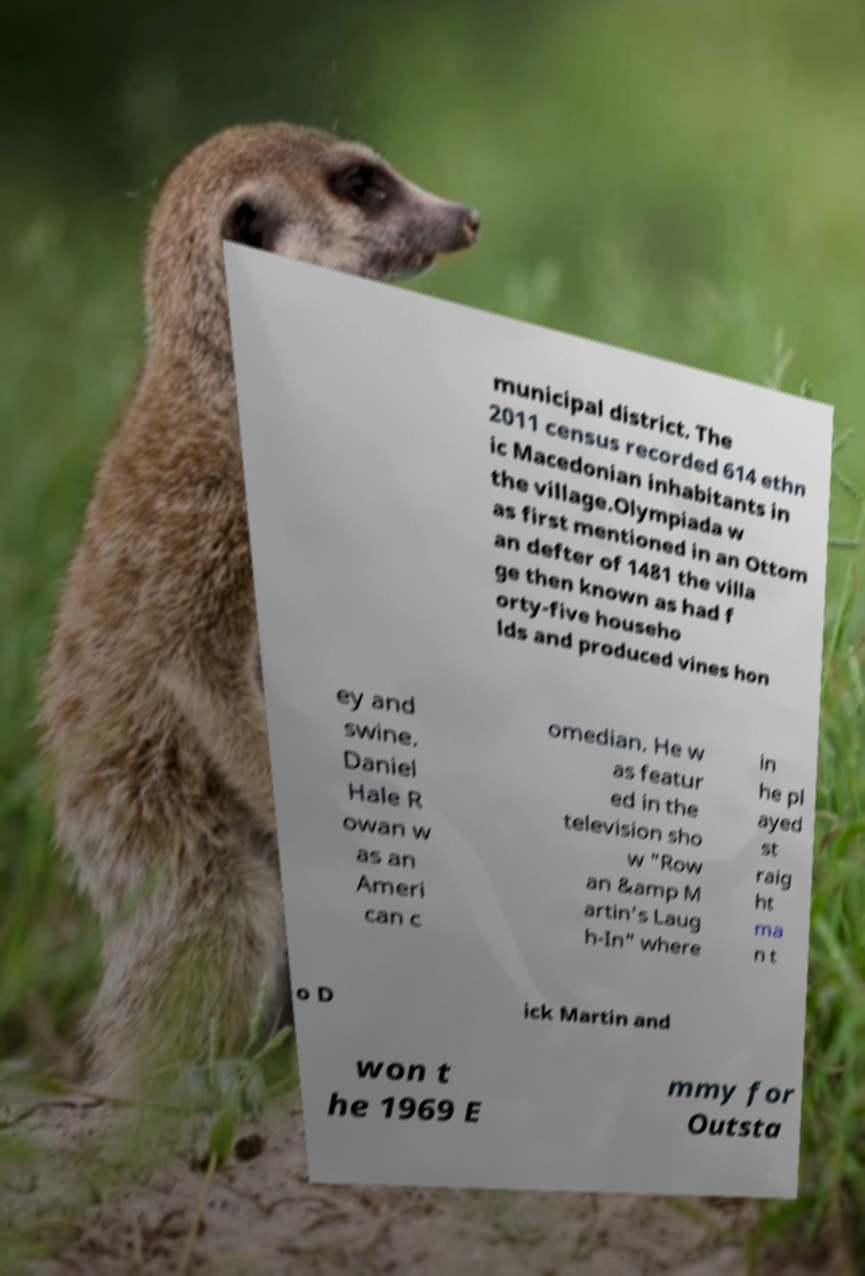Please read and relay the text visible in this image. What does it say? municipal district. The 2011 census recorded 614 ethn ic Macedonian inhabitants in the village.Olympiada w as first mentioned in an Ottom an defter of 1481 the villa ge then known as had f orty-five househo lds and produced vines hon ey and swine. Daniel Hale R owan w as an Ameri can c omedian. He w as featur ed in the television sho w "Row an &amp M artin's Laug h-In" where in he pl ayed st raig ht ma n t o D ick Martin and won t he 1969 E mmy for Outsta 